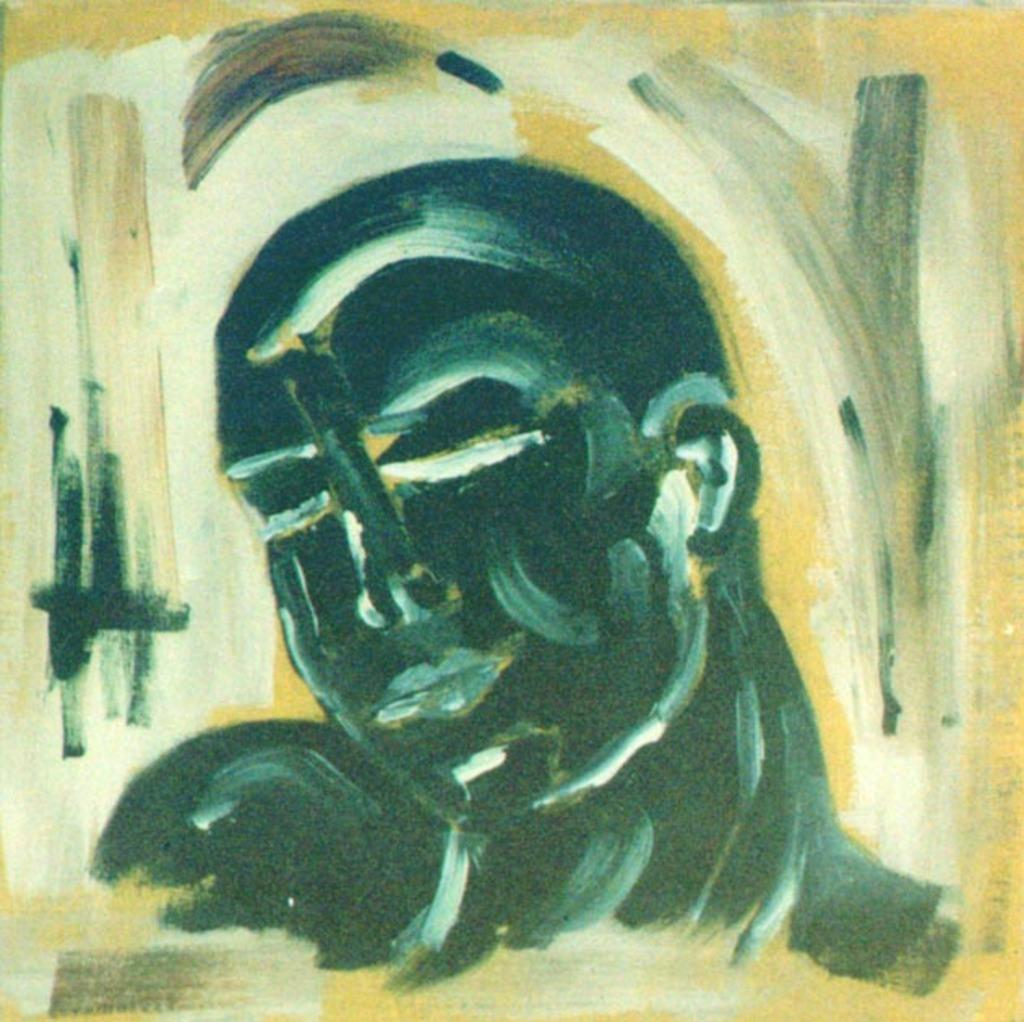What is the main subject of the art piece in the image? The art piece in the image contains a depiction of a human. Can you describe the medium or style of the art piece? Unfortunately, the provided facts do not include information about the medium or style of the art piece. What emotions or themes might the art piece convey? The emotions or themes conveyed by the art piece cannot be determined from the provided facts. What is the title of the art piece in the image? The provided facts do not include information about the title of the art piece. How does the bomb affect the art piece in the image? There is no bomb present in the image, so it cannot affect the art piece. 